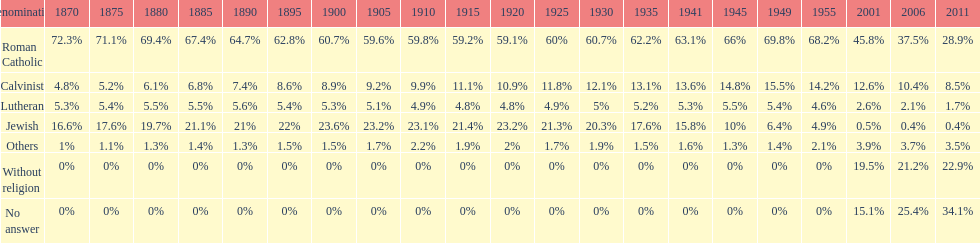What is the largest religious denomination in budapest? Roman Catholic. 